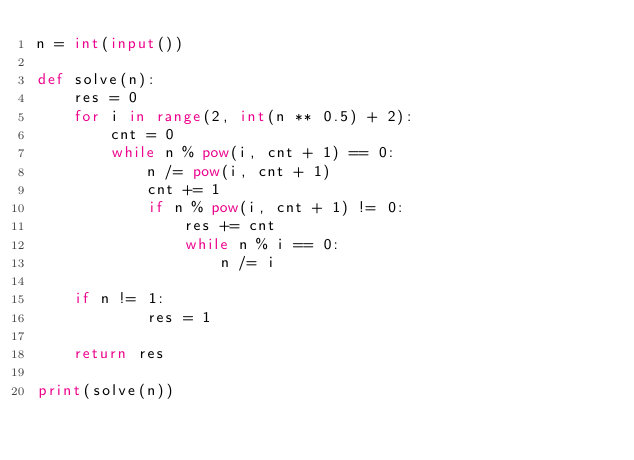Convert code to text. <code><loc_0><loc_0><loc_500><loc_500><_Python_>n = int(input())

def solve(n):
    res = 0
    for i in range(2, int(n ** 0.5) + 2):
        cnt = 0
        while n % pow(i, cnt + 1) == 0:
            n /= pow(i, cnt + 1)
            cnt += 1
            if n % pow(i, cnt + 1) != 0:
                res += cnt
                while n % i == 0:
                    n /= i
    
    if n != 1:
            res = 1
    
    return res

print(solve(n))
</code> 